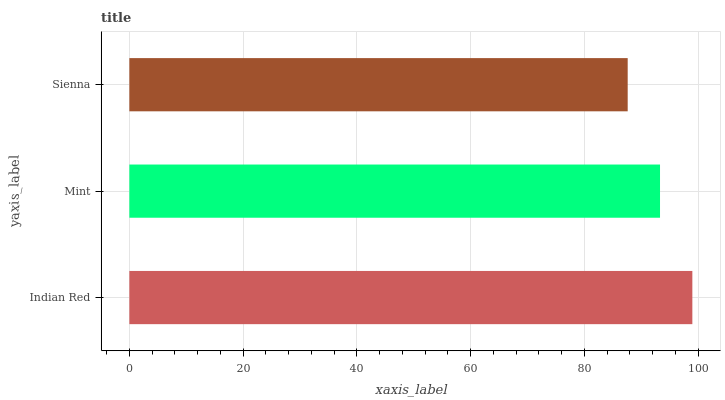Is Sienna the minimum?
Answer yes or no. Yes. Is Indian Red the maximum?
Answer yes or no. Yes. Is Mint the minimum?
Answer yes or no. No. Is Mint the maximum?
Answer yes or no. No. Is Indian Red greater than Mint?
Answer yes or no. Yes. Is Mint less than Indian Red?
Answer yes or no. Yes. Is Mint greater than Indian Red?
Answer yes or no. No. Is Indian Red less than Mint?
Answer yes or no. No. Is Mint the high median?
Answer yes or no. Yes. Is Mint the low median?
Answer yes or no. Yes. Is Indian Red the high median?
Answer yes or no. No. Is Sienna the low median?
Answer yes or no. No. 